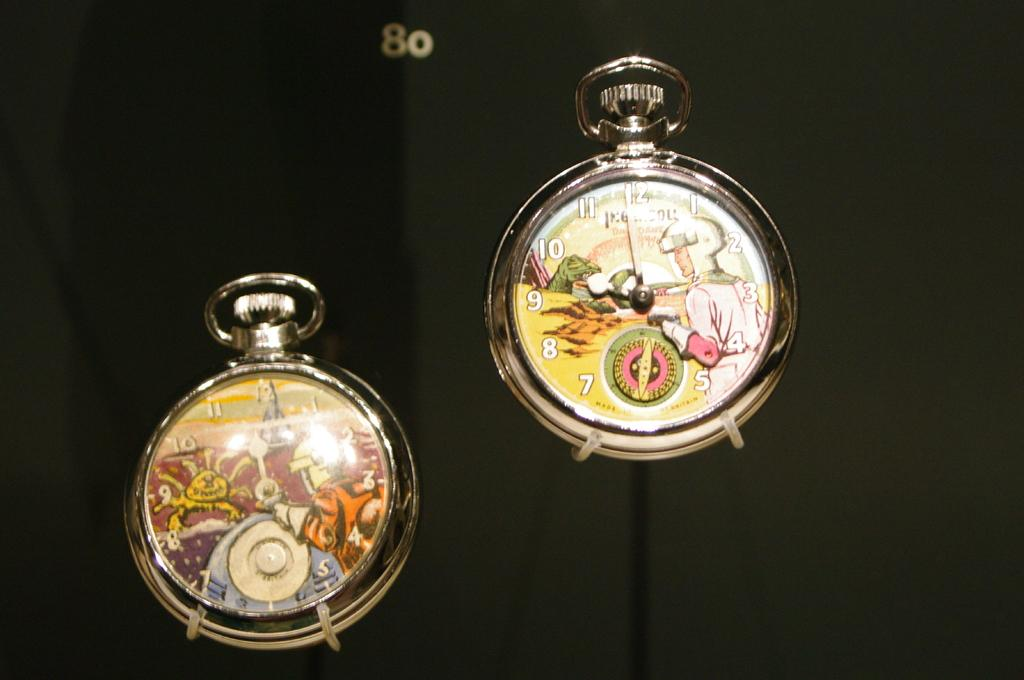Provide a one-sentence caption for the provided image. the letters on a watch with one that says 8. 